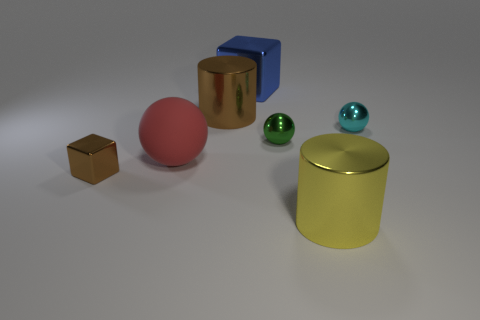Do the block in front of the blue object and the red object behind the brown block have the same material?
Provide a succinct answer. No. There is a cube that is behind the small green metallic sphere; what material is it?
Keep it short and to the point. Metal. Is the material of the brown cylinder the same as the big red ball that is on the left side of the tiny cyan metallic thing?
Ensure brevity in your answer.  No. Is the size of the cube that is behind the big brown metallic object the same as the cylinder behind the tiny cyan sphere?
Offer a terse response. Yes. What number of big brown cylinders are there?
Give a very brief answer. 1. What number of brown blocks are made of the same material as the green object?
Give a very brief answer. 1. Are there the same number of small balls that are in front of the red thing and big metal things?
Provide a short and direct response. No. Do the green metal ball and the cube that is on the left side of the blue metallic block have the same size?
Offer a terse response. Yes. What number of other objects are there of the same size as the green metal thing?
Keep it short and to the point. 2. How many other objects are the same color as the large block?
Make the answer very short. 0. 